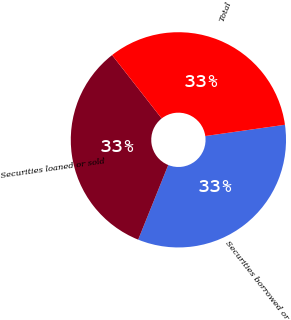<chart> <loc_0><loc_0><loc_500><loc_500><pie_chart><fcel>Securities borrowed or<fcel>Securities loaned or sold<fcel>Total<nl><fcel>33.33%<fcel>33.33%<fcel>33.33%<nl></chart> 